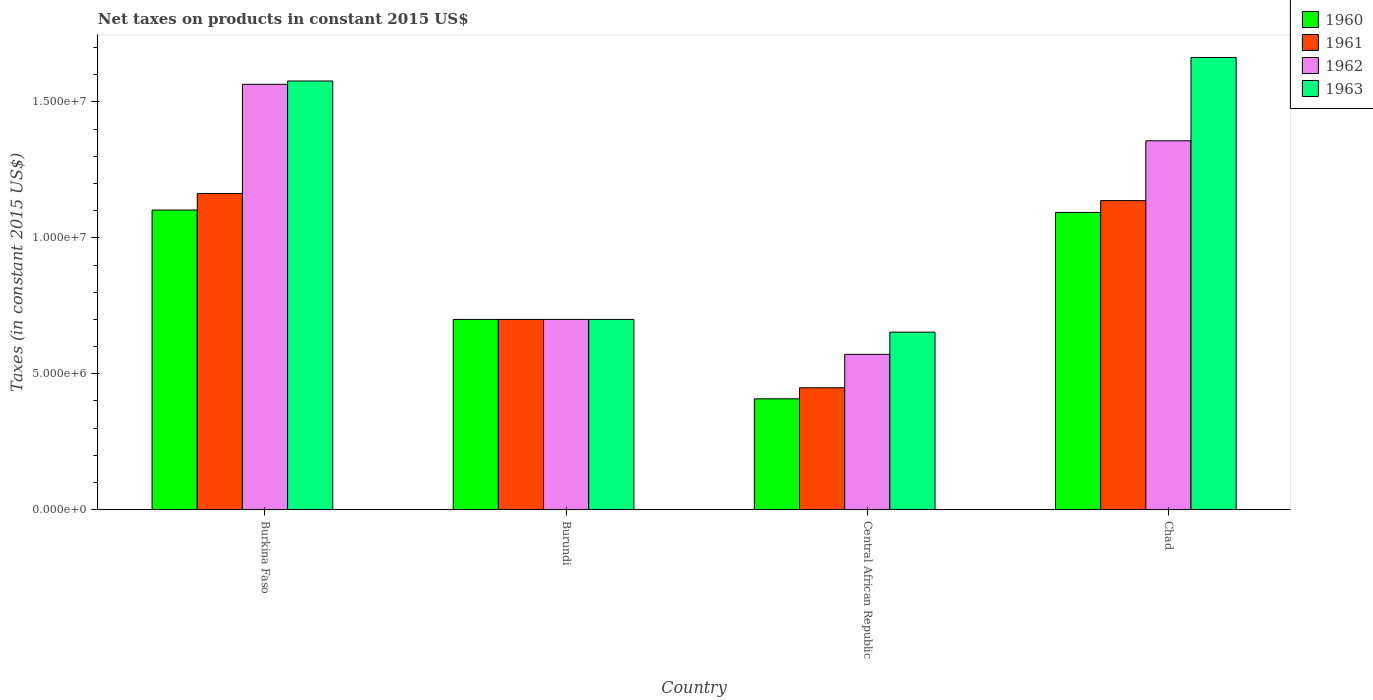How many different coloured bars are there?
Make the answer very short. 4. How many groups of bars are there?
Offer a very short reply. 4. How many bars are there on the 1st tick from the right?
Give a very brief answer. 4. What is the label of the 1st group of bars from the left?
Give a very brief answer. Burkina Faso. In how many cases, is the number of bars for a given country not equal to the number of legend labels?
Provide a succinct answer. 0. What is the net taxes on products in 1963 in Chad?
Offer a very short reply. 1.66e+07. Across all countries, what is the maximum net taxes on products in 1960?
Keep it short and to the point. 1.10e+07. Across all countries, what is the minimum net taxes on products in 1961?
Offer a terse response. 4.49e+06. In which country was the net taxes on products in 1963 maximum?
Offer a terse response. Chad. In which country was the net taxes on products in 1962 minimum?
Your response must be concise. Central African Republic. What is the total net taxes on products in 1963 in the graph?
Provide a short and direct response. 4.59e+07. What is the difference between the net taxes on products in 1960 in Burundi and that in Chad?
Offer a terse response. -3.94e+06. What is the difference between the net taxes on products in 1961 in Burkina Faso and the net taxes on products in 1962 in Burundi?
Give a very brief answer. 4.63e+06. What is the average net taxes on products in 1961 per country?
Keep it short and to the point. 8.62e+06. What is the difference between the net taxes on products of/in 1960 and net taxes on products of/in 1962 in Burkina Faso?
Offer a very short reply. -4.62e+06. What is the ratio of the net taxes on products in 1960 in Burundi to that in Central African Republic?
Your answer should be compact. 1.72. Is the net taxes on products in 1962 in Burkina Faso less than that in Chad?
Ensure brevity in your answer.  No. What is the difference between the highest and the second highest net taxes on products in 1963?
Ensure brevity in your answer.  -8.77e+06. What is the difference between the highest and the lowest net taxes on products in 1960?
Offer a very short reply. 6.94e+06. Is the sum of the net taxes on products in 1962 in Burundi and Central African Republic greater than the maximum net taxes on products in 1961 across all countries?
Make the answer very short. Yes. Is it the case that in every country, the sum of the net taxes on products in 1961 and net taxes on products in 1963 is greater than the sum of net taxes on products in 1960 and net taxes on products in 1962?
Your answer should be very brief. No. What does the 2nd bar from the right in Chad represents?
Provide a succinct answer. 1962. How many bars are there?
Ensure brevity in your answer.  16. Are all the bars in the graph horizontal?
Provide a succinct answer. No. What is the difference between two consecutive major ticks on the Y-axis?
Your answer should be compact. 5.00e+06. Are the values on the major ticks of Y-axis written in scientific E-notation?
Offer a very short reply. Yes. What is the title of the graph?
Offer a very short reply. Net taxes on products in constant 2015 US$. Does "1980" appear as one of the legend labels in the graph?
Provide a short and direct response. No. What is the label or title of the X-axis?
Provide a succinct answer. Country. What is the label or title of the Y-axis?
Offer a very short reply. Taxes (in constant 2015 US$). What is the Taxes (in constant 2015 US$) in 1960 in Burkina Faso?
Your response must be concise. 1.10e+07. What is the Taxes (in constant 2015 US$) of 1961 in Burkina Faso?
Provide a short and direct response. 1.16e+07. What is the Taxes (in constant 2015 US$) of 1962 in Burkina Faso?
Your answer should be compact. 1.56e+07. What is the Taxes (in constant 2015 US$) of 1963 in Burkina Faso?
Your answer should be compact. 1.58e+07. What is the Taxes (in constant 2015 US$) of 1960 in Burundi?
Your answer should be very brief. 7.00e+06. What is the Taxes (in constant 2015 US$) of 1962 in Burundi?
Ensure brevity in your answer.  7.00e+06. What is the Taxes (in constant 2015 US$) in 1960 in Central African Republic?
Provide a short and direct response. 4.08e+06. What is the Taxes (in constant 2015 US$) in 1961 in Central African Republic?
Provide a succinct answer. 4.49e+06. What is the Taxes (in constant 2015 US$) in 1962 in Central African Republic?
Offer a very short reply. 5.71e+06. What is the Taxes (in constant 2015 US$) in 1963 in Central African Republic?
Your response must be concise. 6.53e+06. What is the Taxes (in constant 2015 US$) of 1960 in Chad?
Provide a short and direct response. 1.09e+07. What is the Taxes (in constant 2015 US$) in 1961 in Chad?
Give a very brief answer. 1.14e+07. What is the Taxes (in constant 2015 US$) in 1962 in Chad?
Your response must be concise. 1.36e+07. What is the Taxes (in constant 2015 US$) of 1963 in Chad?
Provide a succinct answer. 1.66e+07. Across all countries, what is the maximum Taxes (in constant 2015 US$) in 1960?
Provide a succinct answer. 1.10e+07. Across all countries, what is the maximum Taxes (in constant 2015 US$) of 1961?
Offer a very short reply. 1.16e+07. Across all countries, what is the maximum Taxes (in constant 2015 US$) of 1962?
Offer a very short reply. 1.56e+07. Across all countries, what is the maximum Taxes (in constant 2015 US$) of 1963?
Your response must be concise. 1.66e+07. Across all countries, what is the minimum Taxes (in constant 2015 US$) of 1960?
Offer a very short reply. 4.08e+06. Across all countries, what is the minimum Taxes (in constant 2015 US$) of 1961?
Offer a terse response. 4.49e+06. Across all countries, what is the minimum Taxes (in constant 2015 US$) in 1962?
Make the answer very short. 5.71e+06. Across all countries, what is the minimum Taxes (in constant 2015 US$) in 1963?
Ensure brevity in your answer.  6.53e+06. What is the total Taxes (in constant 2015 US$) of 1960 in the graph?
Your answer should be compact. 3.30e+07. What is the total Taxes (in constant 2015 US$) in 1961 in the graph?
Give a very brief answer. 3.45e+07. What is the total Taxes (in constant 2015 US$) of 1962 in the graph?
Your response must be concise. 4.19e+07. What is the total Taxes (in constant 2015 US$) of 1963 in the graph?
Give a very brief answer. 4.59e+07. What is the difference between the Taxes (in constant 2015 US$) of 1960 in Burkina Faso and that in Burundi?
Your response must be concise. 4.02e+06. What is the difference between the Taxes (in constant 2015 US$) of 1961 in Burkina Faso and that in Burundi?
Your answer should be compact. 4.63e+06. What is the difference between the Taxes (in constant 2015 US$) in 1962 in Burkina Faso and that in Burundi?
Your answer should be very brief. 8.65e+06. What is the difference between the Taxes (in constant 2015 US$) of 1963 in Burkina Faso and that in Burundi?
Offer a terse response. 8.77e+06. What is the difference between the Taxes (in constant 2015 US$) of 1960 in Burkina Faso and that in Central African Republic?
Your response must be concise. 6.94e+06. What is the difference between the Taxes (in constant 2015 US$) of 1961 in Burkina Faso and that in Central African Republic?
Make the answer very short. 7.15e+06. What is the difference between the Taxes (in constant 2015 US$) of 1962 in Burkina Faso and that in Central African Republic?
Give a very brief answer. 9.93e+06. What is the difference between the Taxes (in constant 2015 US$) in 1963 in Burkina Faso and that in Central African Republic?
Offer a terse response. 9.24e+06. What is the difference between the Taxes (in constant 2015 US$) of 1960 in Burkina Faso and that in Chad?
Offer a terse response. 8.71e+04. What is the difference between the Taxes (in constant 2015 US$) of 1961 in Burkina Faso and that in Chad?
Ensure brevity in your answer.  2.61e+05. What is the difference between the Taxes (in constant 2015 US$) in 1962 in Burkina Faso and that in Chad?
Provide a short and direct response. 2.08e+06. What is the difference between the Taxes (in constant 2015 US$) in 1963 in Burkina Faso and that in Chad?
Provide a short and direct response. -8.65e+05. What is the difference between the Taxes (in constant 2015 US$) of 1960 in Burundi and that in Central African Republic?
Offer a very short reply. 2.92e+06. What is the difference between the Taxes (in constant 2015 US$) in 1961 in Burundi and that in Central African Republic?
Ensure brevity in your answer.  2.51e+06. What is the difference between the Taxes (in constant 2015 US$) in 1962 in Burundi and that in Central African Republic?
Give a very brief answer. 1.29e+06. What is the difference between the Taxes (in constant 2015 US$) in 1963 in Burundi and that in Central African Republic?
Make the answer very short. 4.70e+05. What is the difference between the Taxes (in constant 2015 US$) in 1960 in Burundi and that in Chad?
Your answer should be compact. -3.94e+06. What is the difference between the Taxes (in constant 2015 US$) of 1961 in Burundi and that in Chad?
Your answer should be very brief. -4.37e+06. What is the difference between the Taxes (in constant 2015 US$) in 1962 in Burundi and that in Chad?
Ensure brevity in your answer.  -6.57e+06. What is the difference between the Taxes (in constant 2015 US$) of 1963 in Burundi and that in Chad?
Provide a short and direct response. -9.63e+06. What is the difference between the Taxes (in constant 2015 US$) of 1960 in Central African Republic and that in Chad?
Provide a succinct answer. -6.86e+06. What is the difference between the Taxes (in constant 2015 US$) in 1961 in Central African Republic and that in Chad?
Offer a very short reply. -6.88e+06. What is the difference between the Taxes (in constant 2015 US$) of 1962 in Central African Republic and that in Chad?
Provide a succinct answer. -7.86e+06. What is the difference between the Taxes (in constant 2015 US$) of 1963 in Central African Republic and that in Chad?
Ensure brevity in your answer.  -1.01e+07. What is the difference between the Taxes (in constant 2015 US$) in 1960 in Burkina Faso and the Taxes (in constant 2015 US$) in 1961 in Burundi?
Offer a very short reply. 4.02e+06. What is the difference between the Taxes (in constant 2015 US$) in 1960 in Burkina Faso and the Taxes (in constant 2015 US$) in 1962 in Burundi?
Ensure brevity in your answer.  4.02e+06. What is the difference between the Taxes (in constant 2015 US$) in 1960 in Burkina Faso and the Taxes (in constant 2015 US$) in 1963 in Burundi?
Your answer should be compact. 4.02e+06. What is the difference between the Taxes (in constant 2015 US$) in 1961 in Burkina Faso and the Taxes (in constant 2015 US$) in 1962 in Burundi?
Offer a very short reply. 4.63e+06. What is the difference between the Taxes (in constant 2015 US$) in 1961 in Burkina Faso and the Taxes (in constant 2015 US$) in 1963 in Burundi?
Your answer should be very brief. 4.63e+06. What is the difference between the Taxes (in constant 2015 US$) in 1962 in Burkina Faso and the Taxes (in constant 2015 US$) in 1963 in Burundi?
Give a very brief answer. 8.65e+06. What is the difference between the Taxes (in constant 2015 US$) of 1960 in Burkina Faso and the Taxes (in constant 2015 US$) of 1961 in Central African Republic?
Your response must be concise. 6.54e+06. What is the difference between the Taxes (in constant 2015 US$) in 1960 in Burkina Faso and the Taxes (in constant 2015 US$) in 1962 in Central African Republic?
Your answer should be compact. 5.31e+06. What is the difference between the Taxes (in constant 2015 US$) in 1960 in Burkina Faso and the Taxes (in constant 2015 US$) in 1963 in Central African Republic?
Provide a short and direct response. 4.49e+06. What is the difference between the Taxes (in constant 2015 US$) of 1961 in Burkina Faso and the Taxes (in constant 2015 US$) of 1962 in Central African Republic?
Provide a succinct answer. 5.92e+06. What is the difference between the Taxes (in constant 2015 US$) of 1961 in Burkina Faso and the Taxes (in constant 2015 US$) of 1963 in Central African Republic?
Your answer should be very brief. 5.10e+06. What is the difference between the Taxes (in constant 2015 US$) in 1962 in Burkina Faso and the Taxes (in constant 2015 US$) in 1963 in Central African Republic?
Ensure brevity in your answer.  9.12e+06. What is the difference between the Taxes (in constant 2015 US$) of 1960 in Burkina Faso and the Taxes (in constant 2015 US$) of 1961 in Chad?
Ensure brevity in your answer.  -3.47e+05. What is the difference between the Taxes (in constant 2015 US$) of 1960 in Burkina Faso and the Taxes (in constant 2015 US$) of 1962 in Chad?
Offer a terse response. -2.55e+06. What is the difference between the Taxes (in constant 2015 US$) in 1960 in Burkina Faso and the Taxes (in constant 2015 US$) in 1963 in Chad?
Offer a terse response. -5.61e+06. What is the difference between the Taxes (in constant 2015 US$) in 1961 in Burkina Faso and the Taxes (in constant 2015 US$) in 1962 in Chad?
Your answer should be compact. -1.94e+06. What is the difference between the Taxes (in constant 2015 US$) in 1961 in Burkina Faso and the Taxes (in constant 2015 US$) in 1963 in Chad?
Provide a short and direct response. -5.00e+06. What is the difference between the Taxes (in constant 2015 US$) in 1962 in Burkina Faso and the Taxes (in constant 2015 US$) in 1963 in Chad?
Offer a very short reply. -9.87e+05. What is the difference between the Taxes (in constant 2015 US$) in 1960 in Burundi and the Taxes (in constant 2015 US$) in 1961 in Central African Republic?
Offer a very short reply. 2.51e+06. What is the difference between the Taxes (in constant 2015 US$) of 1960 in Burundi and the Taxes (in constant 2015 US$) of 1962 in Central African Republic?
Offer a very short reply. 1.29e+06. What is the difference between the Taxes (in constant 2015 US$) of 1960 in Burundi and the Taxes (in constant 2015 US$) of 1963 in Central African Republic?
Your answer should be very brief. 4.70e+05. What is the difference between the Taxes (in constant 2015 US$) in 1961 in Burundi and the Taxes (in constant 2015 US$) in 1962 in Central African Republic?
Provide a short and direct response. 1.29e+06. What is the difference between the Taxes (in constant 2015 US$) in 1961 in Burundi and the Taxes (in constant 2015 US$) in 1963 in Central African Republic?
Your answer should be compact. 4.70e+05. What is the difference between the Taxes (in constant 2015 US$) of 1962 in Burundi and the Taxes (in constant 2015 US$) of 1963 in Central African Republic?
Keep it short and to the point. 4.70e+05. What is the difference between the Taxes (in constant 2015 US$) of 1960 in Burundi and the Taxes (in constant 2015 US$) of 1961 in Chad?
Your response must be concise. -4.37e+06. What is the difference between the Taxes (in constant 2015 US$) of 1960 in Burundi and the Taxes (in constant 2015 US$) of 1962 in Chad?
Make the answer very short. -6.57e+06. What is the difference between the Taxes (in constant 2015 US$) in 1960 in Burundi and the Taxes (in constant 2015 US$) in 1963 in Chad?
Provide a short and direct response. -9.63e+06. What is the difference between the Taxes (in constant 2015 US$) of 1961 in Burundi and the Taxes (in constant 2015 US$) of 1962 in Chad?
Make the answer very short. -6.57e+06. What is the difference between the Taxes (in constant 2015 US$) in 1961 in Burundi and the Taxes (in constant 2015 US$) in 1963 in Chad?
Your response must be concise. -9.63e+06. What is the difference between the Taxes (in constant 2015 US$) in 1962 in Burundi and the Taxes (in constant 2015 US$) in 1963 in Chad?
Your answer should be very brief. -9.63e+06. What is the difference between the Taxes (in constant 2015 US$) in 1960 in Central African Republic and the Taxes (in constant 2015 US$) in 1961 in Chad?
Your answer should be compact. -7.29e+06. What is the difference between the Taxes (in constant 2015 US$) in 1960 in Central African Republic and the Taxes (in constant 2015 US$) in 1962 in Chad?
Provide a succinct answer. -9.49e+06. What is the difference between the Taxes (in constant 2015 US$) of 1960 in Central African Republic and the Taxes (in constant 2015 US$) of 1963 in Chad?
Keep it short and to the point. -1.26e+07. What is the difference between the Taxes (in constant 2015 US$) in 1961 in Central African Republic and the Taxes (in constant 2015 US$) in 1962 in Chad?
Offer a terse response. -9.08e+06. What is the difference between the Taxes (in constant 2015 US$) in 1961 in Central African Republic and the Taxes (in constant 2015 US$) in 1963 in Chad?
Your answer should be very brief. -1.21e+07. What is the difference between the Taxes (in constant 2015 US$) of 1962 in Central African Republic and the Taxes (in constant 2015 US$) of 1963 in Chad?
Your answer should be very brief. -1.09e+07. What is the average Taxes (in constant 2015 US$) in 1960 per country?
Provide a succinct answer. 8.26e+06. What is the average Taxes (in constant 2015 US$) in 1961 per country?
Your response must be concise. 8.62e+06. What is the average Taxes (in constant 2015 US$) of 1962 per country?
Ensure brevity in your answer.  1.05e+07. What is the average Taxes (in constant 2015 US$) of 1963 per country?
Ensure brevity in your answer.  1.15e+07. What is the difference between the Taxes (in constant 2015 US$) of 1960 and Taxes (in constant 2015 US$) of 1961 in Burkina Faso?
Offer a terse response. -6.08e+05. What is the difference between the Taxes (in constant 2015 US$) of 1960 and Taxes (in constant 2015 US$) of 1962 in Burkina Faso?
Offer a terse response. -4.62e+06. What is the difference between the Taxes (in constant 2015 US$) of 1960 and Taxes (in constant 2015 US$) of 1963 in Burkina Faso?
Make the answer very short. -4.75e+06. What is the difference between the Taxes (in constant 2015 US$) in 1961 and Taxes (in constant 2015 US$) in 1962 in Burkina Faso?
Give a very brief answer. -4.02e+06. What is the difference between the Taxes (in constant 2015 US$) in 1961 and Taxes (in constant 2015 US$) in 1963 in Burkina Faso?
Offer a very short reply. -4.14e+06. What is the difference between the Taxes (in constant 2015 US$) in 1962 and Taxes (in constant 2015 US$) in 1963 in Burkina Faso?
Offer a terse response. -1.22e+05. What is the difference between the Taxes (in constant 2015 US$) in 1960 and Taxes (in constant 2015 US$) in 1961 in Burundi?
Your answer should be compact. 0. What is the difference between the Taxes (in constant 2015 US$) of 1960 and Taxes (in constant 2015 US$) of 1963 in Burundi?
Offer a very short reply. 0. What is the difference between the Taxes (in constant 2015 US$) in 1962 and Taxes (in constant 2015 US$) in 1963 in Burundi?
Offer a very short reply. 0. What is the difference between the Taxes (in constant 2015 US$) in 1960 and Taxes (in constant 2015 US$) in 1961 in Central African Republic?
Your answer should be very brief. -4.07e+05. What is the difference between the Taxes (in constant 2015 US$) of 1960 and Taxes (in constant 2015 US$) of 1962 in Central African Republic?
Make the answer very short. -1.64e+06. What is the difference between the Taxes (in constant 2015 US$) of 1960 and Taxes (in constant 2015 US$) of 1963 in Central African Republic?
Provide a short and direct response. -2.45e+06. What is the difference between the Taxes (in constant 2015 US$) in 1961 and Taxes (in constant 2015 US$) in 1962 in Central African Republic?
Provide a short and direct response. -1.23e+06. What is the difference between the Taxes (in constant 2015 US$) of 1961 and Taxes (in constant 2015 US$) of 1963 in Central African Republic?
Your answer should be compact. -2.05e+06. What is the difference between the Taxes (in constant 2015 US$) of 1962 and Taxes (in constant 2015 US$) of 1963 in Central African Republic?
Give a very brief answer. -8.16e+05. What is the difference between the Taxes (in constant 2015 US$) of 1960 and Taxes (in constant 2015 US$) of 1961 in Chad?
Provide a succinct answer. -4.34e+05. What is the difference between the Taxes (in constant 2015 US$) of 1960 and Taxes (in constant 2015 US$) of 1962 in Chad?
Provide a short and direct response. -2.63e+06. What is the difference between the Taxes (in constant 2015 US$) in 1960 and Taxes (in constant 2015 US$) in 1963 in Chad?
Keep it short and to the point. -5.70e+06. What is the difference between the Taxes (in constant 2015 US$) in 1961 and Taxes (in constant 2015 US$) in 1962 in Chad?
Provide a succinct answer. -2.20e+06. What is the difference between the Taxes (in constant 2015 US$) in 1961 and Taxes (in constant 2015 US$) in 1963 in Chad?
Your response must be concise. -5.26e+06. What is the difference between the Taxes (in constant 2015 US$) in 1962 and Taxes (in constant 2015 US$) in 1963 in Chad?
Make the answer very short. -3.06e+06. What is the ratio of the Taxes (in constant 2015 US$) of 1960 in Burkina Faso to that in Burundi?
Make the answer very short. 1.57. What is the ratio of the Taxes (in constant 2015 US$) of 1961 in Burkina Faso to that in Burundi?
Ensure brevity in your answer.  1.66. What is the ratio of the Taxes (in constant 2015 US$) in 1962 in Burkina Faso to that in Burundi?
Keep it short and to the point. 2.24. What is the ratio of the Taxes (in constant 2015 US$) of 1963 in Burkina Faso to that in Burundi?
Your answer should be very brief. 2.25. What is the ratio of the Taxes (in constant 2015 US$) in 1960 in Burkina Faso to that in Central African Republic?
Your answer should be compact. 2.7. What is the ratio of the Taxes (in constant 2015 US$) in 1961 in Burkina Faso to that in Central African Republic?
Ensure brevity in your answer.  2.59. What is the ratio of the Taxes (in constant 2015 US$) in 1962 in Burkina Faso to that in Central African Republic?
Provide a short and direct response. 2.74. What is the ratio of the Taxes (in constant 2015 US$) in 1963 in Burkina Faso to that in Central African Republic?
Offer a very short reply. 2.41. What is the ratio of the Taxes (in constant 2015 US$) in 1960 in Burkina Faso to that in Chad?
Your answer should be very brief. 1.01. What is the ratio of the Taxes (in constant 2015 US$) in 1961 in Burkina Faso to that in Chad?
Offer a terse response. 1.02. What is the ratio of the Taxes (in constant 2015 US$) in 1962 in Burkina Faso to that in Chad?
Your answer should be very brief. 1.15. What is the ratio of the Taxes (in constant 2015 US$) in 1963 in Burkina Faso to that in Chad?
Offer a terse response. 0.95. What is the ratio of the Taxes (in constant 2015 US$) in 1960 in Burundi to that in Central African Republic?
Ensure brevity in your answer.  1.72. What is the ratio of the Taxes (in constant 2015 US$) of 1961 in Burundi to that in Central African Republic?
Provide a short and direct response. 1.56. What is the ratio of the Taxes (in constant 2015 US$) of 1962 in Burundi to that in Central African Republic?
Give a very brief answer. 1.23. What is the ratio of the Taxes (in constant 2015 US$) in 1963 in Burundi to that in Central African Republic?
Ensure brevity in your answer.  1.07. What is the ratio of the Taxes (in constant 2015 US$) in 1960 in Burundi to that in Chad?
Keep it short and to the point. 0.64. What is the ratio of the Taxes (in constant 2015 US$) in 1961 in Burundi to that in Chad?
Offer a very short reply. 0.62. What is the ratio of the Taxes (in constant 2015 US$) in 1962 in Burundi to that in Chad?
Give a very brief answer. 0.52. What is the ratio of the Taxes (in constant 2015 US$) in 1963 in Burundi to that in Chad?
Keep it short and to the point. 0.42. What is the ratio of the Taxes (in constant 2015 US$) of 1960 in Central African Republic to that in Chad?
Keep it short and to the point. 0.37. What is the ratio of the Taxes (in constant 2015 US$) of 1961 in Central African Republic to that in Chad?
Provide a succinct answer. 0.39. What is the ratio of the Taxes (in constant 2015 US$) of 1962 in Central African Republic to that in Chad?
Offer a terse response. 0.42. What is the ratio of the Taxes (in constant 2015 US$) of 1963 in Central African Republic to that in Chad?
Keep it short and to the point. 0.39. What is the difference between the highest and the second highest Taxes (in constant 2015 US$) in 1960?
Your answer should be compact. 8.71e+04. What is the difference between the highest and the second highest Taxes (in constant 2015 US$) of 1961?
Ensure brevity in your answer.  2.61e+05. What is the difference between the highest and the second highest Taxes (in constant 2015 US$) in 1962?
Your answer should be compact. 2.08e+06. What is the difference between the highest and the second highest Taxes (in constant 2015 US$) in 1963?
Give a very brief answer. 8.65e+05. What is the difference between the highest and the lowest Taxes (in constant 2015 US$) in 1960?
Offer a terse response. 6.94e+06. What is the difference between the highest and the lowest Taxes (in constant 2015 US$) of 1961?
Give a very brief answer. 7.15e+06. What is the difference between the highest and the lowest Taxes (in constant 2015 US$) of 1962?
Your answer should be compact. 9.93e+06. What is the difference between the highest and the lowest Taxes (in constant 2015 US$) of 1963?
Offer a very short reply. 1.01e+07. 